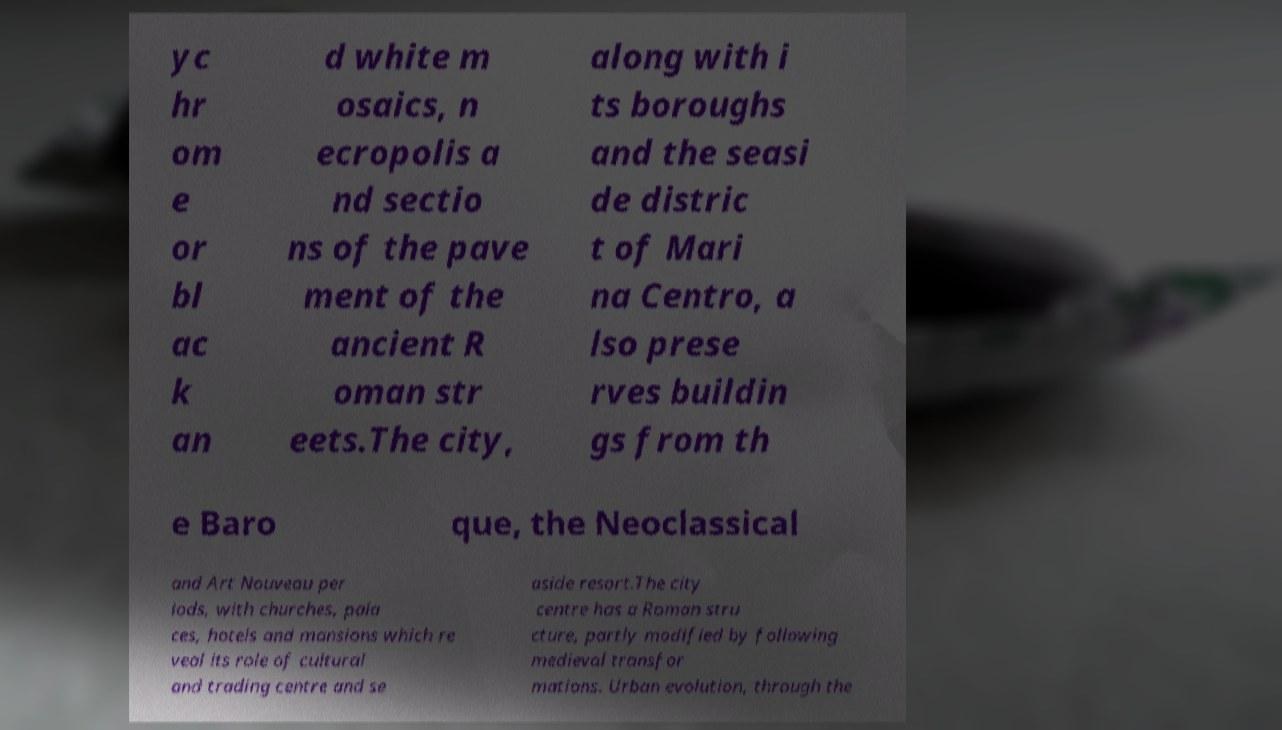Could you extract and type out the text from this image? yc hr om e or bl ac k an d white m osaics, n ecropolis a nd sectio ns of the pave ment of the ancient R oman str eets.The city, along with i ts boroughs and the seasi de distric t of Mari na Centro, a lso prese rves buildin gs from th e Baro que, the Neoclassical and Art Nouveau per iods, with churches, pala ces, hotels and mansions which re veal its role of cultural and trading centre and se aside resort.The city centre has a Roman stru cture, partly modified by following medieval transfor mations. Urban evolution, through the 